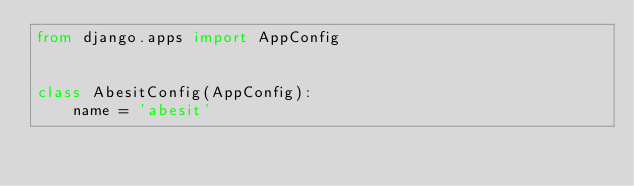<code> <loc_0><loc_0><loc_500><loc_500><_Python_>from django.apps import AppConfig


class AbesitConfig(AppConfig):
    name = 'abesit'
</code> 